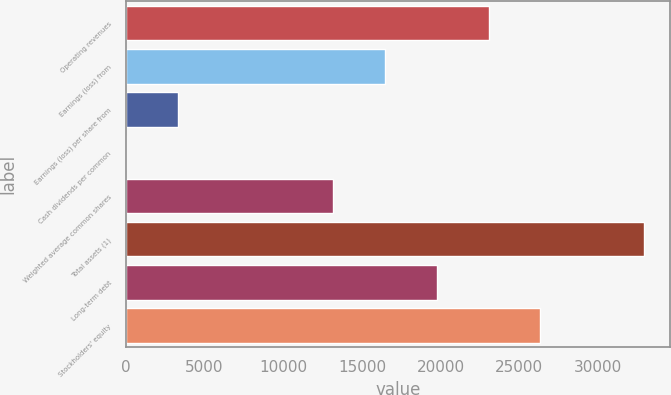Convert chart to OTSL. <chart><loc_0><loc_0><loc_500><loc_500><bar_chart><fcel>Operating revenues<fcel>Earnings (loss) from<fcel>Earnings (loss) per share from<fcel>Cash dividends per common<fcel>Weighted average common shares<fcel>Total assets (1)<fcel>Long-term debt<fcel>Stockholders' equity<nl><fcel>23049.1<fcel>16463.8<fcel>3293.28<fcel>0.64<fcel>13171.2<fcel>32927<fcel>19756.5<fcel>26341.8<nl></chart> 